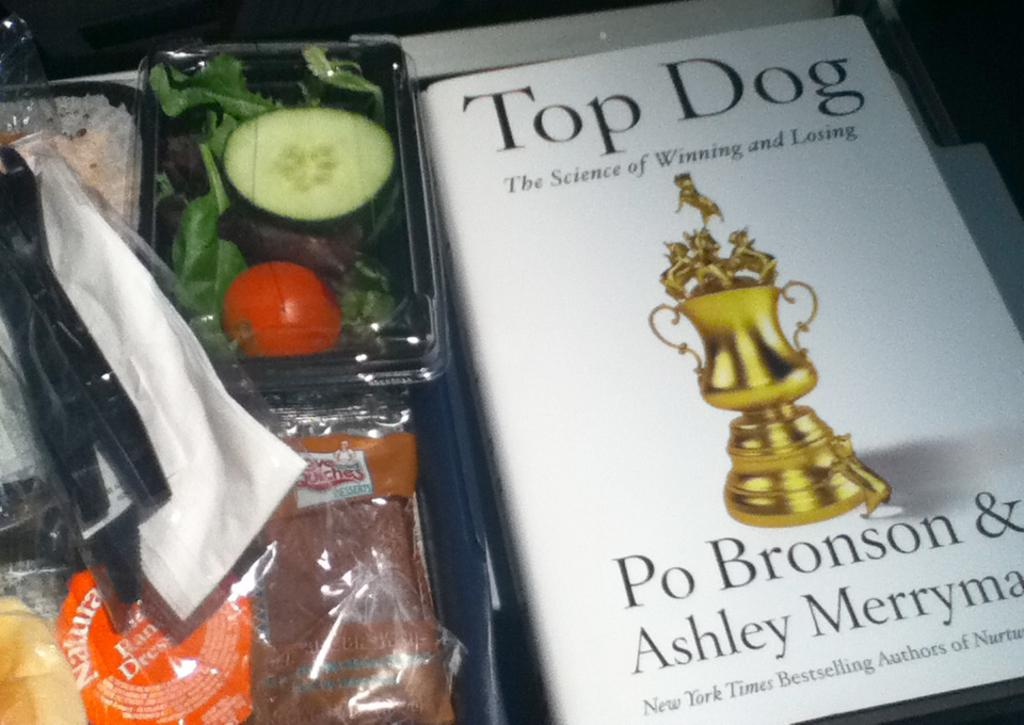<image>
Present a compact description of the photo's key features. Book titled Top Dog next to some vegetables. 